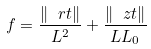Convert formula to latex. <formula><loc_0><loc_0><loc_500><loc_500>f = \frac { \| \ r t \| } { L ^ { 2 } } + \frac { \| \ z t \| } { L L _ { 0 } }</formula> 